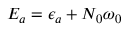<formula> <loc_0><loc_0><loc_500><loc_500>E _ { a } = \epsilon _ { a } + N _ { 0 } \omega _ { 0 }</formula> 